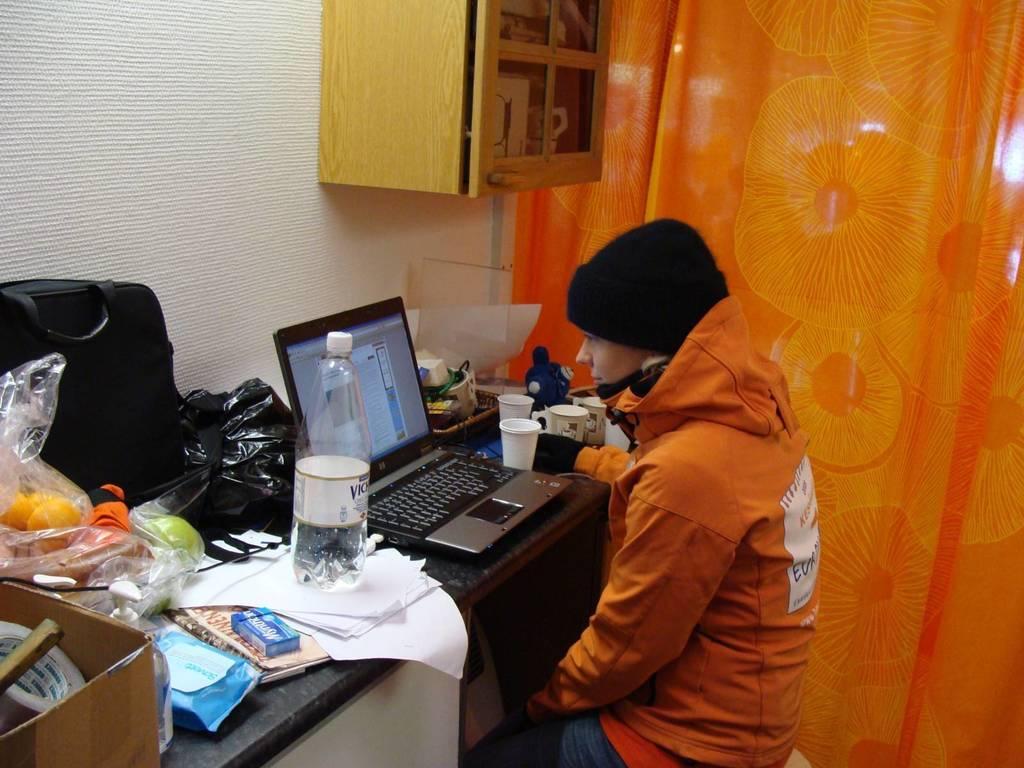Could you give a brief overview of what you see in this image? This man is sitting on a chair. In-front of this man there is a table. On a table there is a bottle, plastic cover, bag, laptop, cup and things. This is a cupboard with things. This is an orange curtain. 